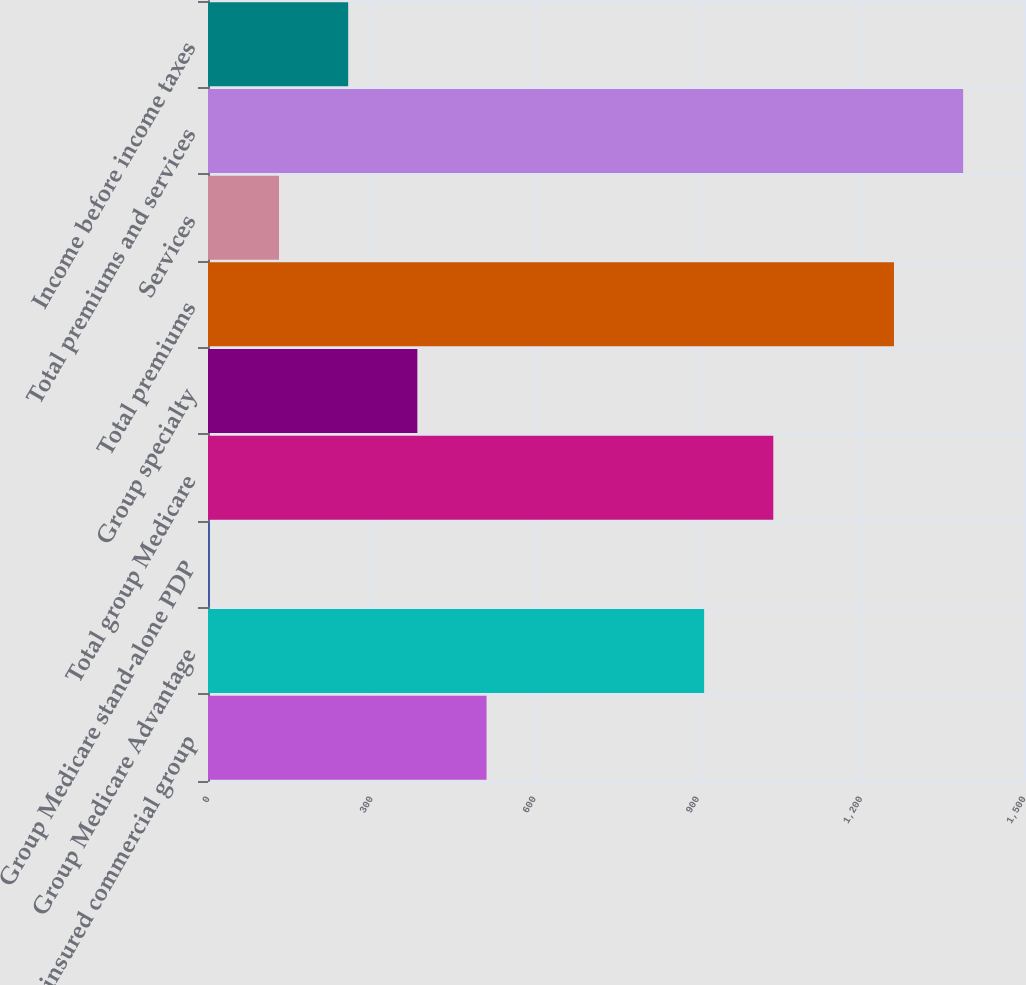Convert chart to OTSL. <chart><loc_0><loc_0><loc_500><loc_500><bar_chart><fcel>Fully-insured commercial group<fcel>Group Medicare Advantage<fcel>Group Medicare stand-alone PDP<fcel>Total group Medicare<fcel>Group specialty<fcel>Total premiums<fcel>Services<fcel>Total premiums and services<fcel>Income before income taxes<nl><fcel>512.01<fcel>912<fcel>3.37<fcel>1039.16<fcel>384.85<fcel>1261<fcel>130.53<fcel>1388.16<fcel>257.69<nl></chart> 